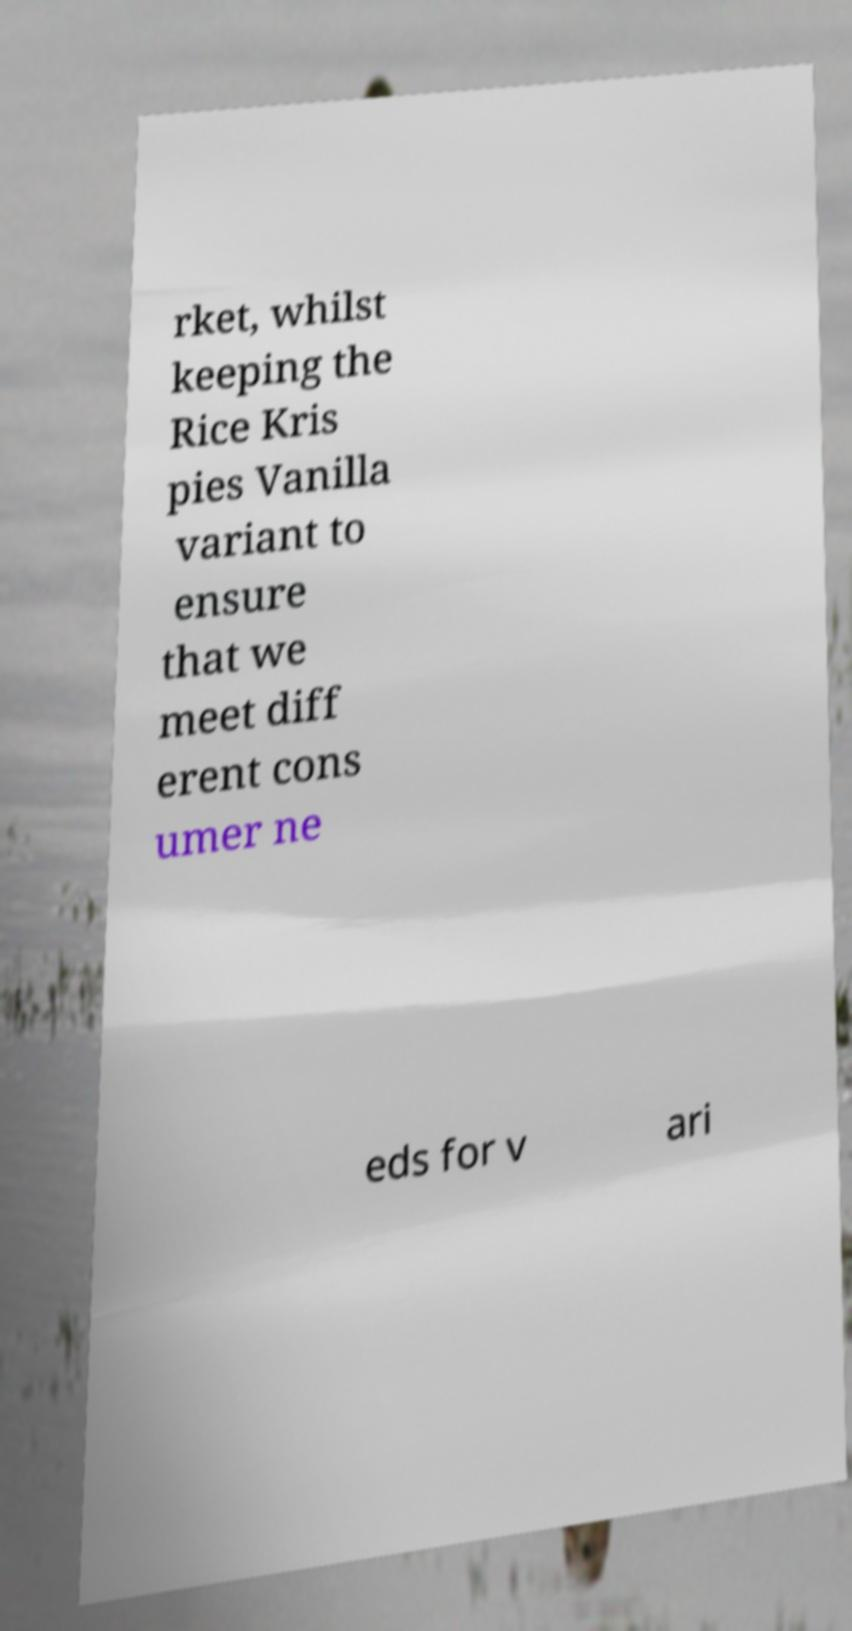Could you extract and type out the text from this image? rket, whilst keeping the Rice Kris pies Vanilla variant to ensure that we meet diff erent cons umer ne eds for v ari 